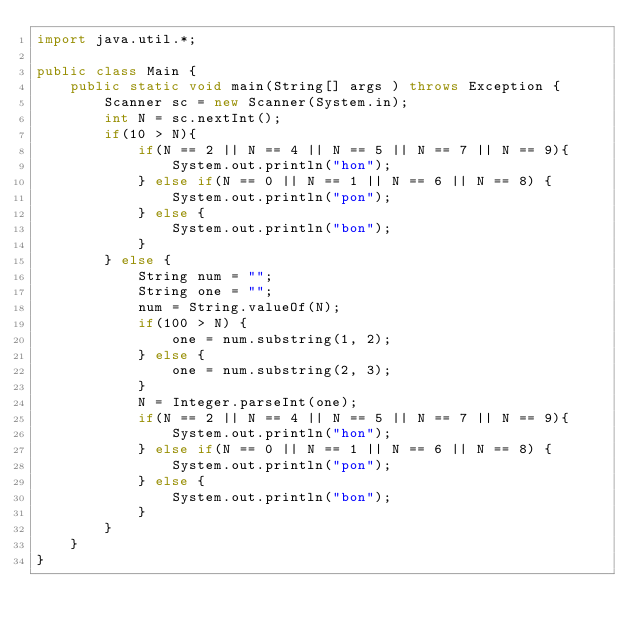<code> <loc_0><loc_0><loc_500><loc_500><_Java_>import java.util.*;

public class Main {
    public static void main(String[] args ) throws Exception {
        Scanner sc = new Scanner(System.in);
        int N = sc.nextInt();
        if(10 > N){
            if(N == 2 || N == 4 || N == 5 || N == 7 || N == 9){
                System.out.println("hon");
            } else if(N == 0 || N == 1 || N == 6 || N == 8) {
                System.out.println("pon");
            } else {
                System.out.println("bon");
            }
        } else {
            String num = "";
            String one = "";
            num = String.valueOf(N);
            if(100 > N) {
                one = num.substring(1, 2);
            } else {
                one = num.substring(2, 3);
            }
            N = Integer.parseInt(one);
            if(N == 2 || N == 4 || N == 5 || N == 7 || N == 9){
                System.out.println("hon");
            } else if(N == 0 || N == 1 || N == 6 || N == 8) {
                System.out.println("pon");
            } else {
                System.out.println("bon");
            }
        }
    }
}
</code> 